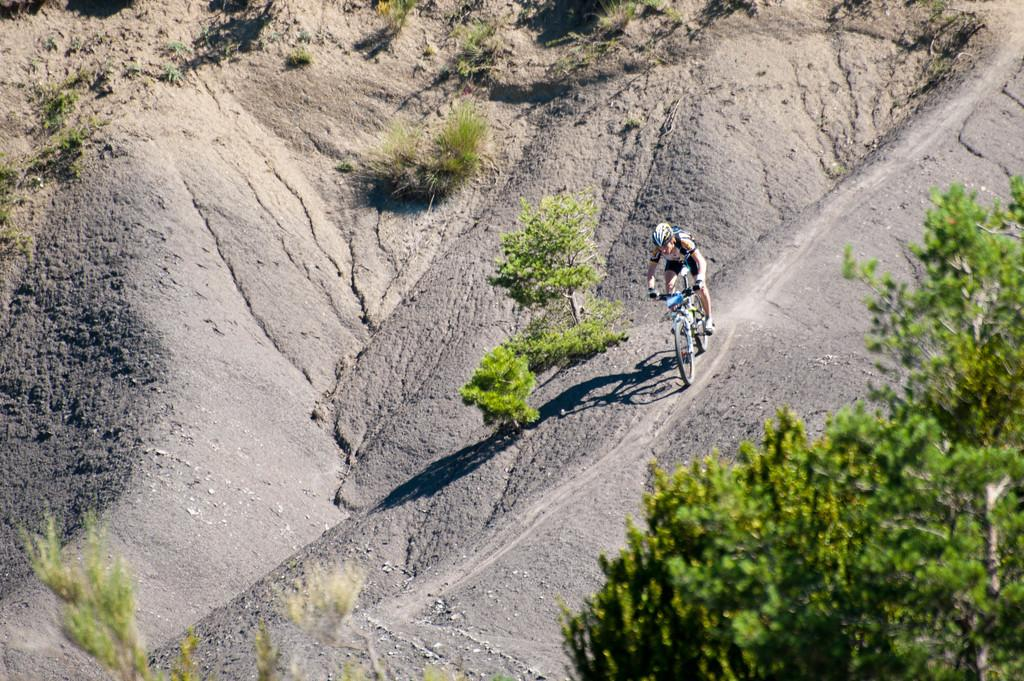What is the person in the image doing? The person is cycling in the image. Where is the person cycling? The person is on a path in the image. What can be seen in the background of the image? There are trees and plants in the image. What type of box is the farmer carrying in the image? There is no farmer or box present in the image; it features a person cycling on a path with trees and plants in the background. 